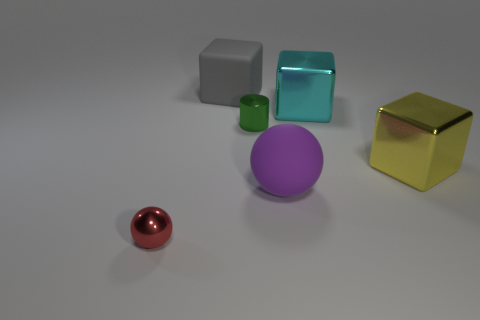Subtract all large yellow cubes. How many cubes are left? 2 Add 2 tiny cyan metallic things. How many objects exist? 8 Subtract all cyan cubes. How many red balls are left? 1 Subtract all small blue matte balls. Subtract all small green cylinders. How many objects are left? 5 Add 3 objects. How many objects are left? 9 Add 5 cyan metallic balls. How many cyan metallic balls exist? 5 Subtract all red balls. How many balls are left? 1 Subtract 1 green cylinders. How many objects are left? 5 Subtract all spheres. How many objects are left? 4 Subtract 1 cylinders. How many cylinders are left? 0 